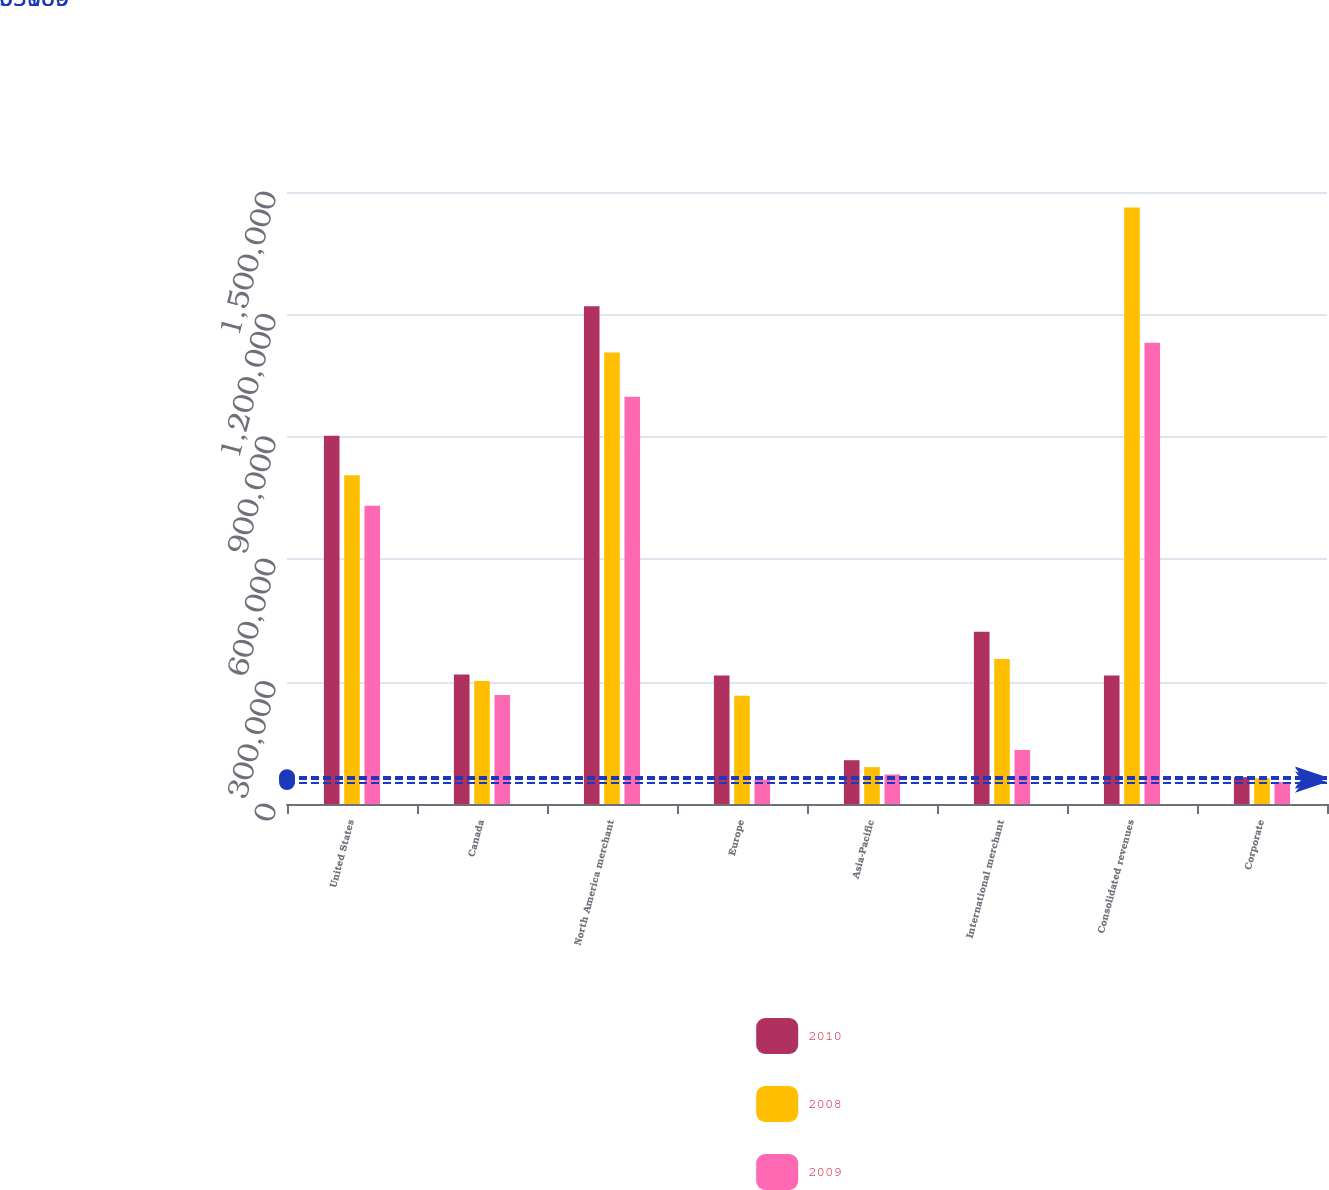Convert chart. <chart><loc_0><loc_0><loc_500><loc_500><stacked_bar_chart><ecel><fcel>United States<fcel>Canada<fcel>North America merchant<fcel>Europe<fcel>Asia-Pacific<fcel>International merchant<fcel>Consolidated revenues<fcel>Corporate<nl><fcel>2010<fcel>902844<fcel>317272<fcel>1.22012e+06<fcel>315023<fcel>107329<fcel>422352<fcel>315023<fcel>65806<nl><fcel>2008<fcel>805557<fcel>301294<fcel>1.10685e+06<fcel>265121<fcel>90334<fcel>355455<fcel>1.46231e+06<fcel>63189<nl><fcel>2009<fcel>731214<fcel>267249<fcel>998463<fcel>59778<fcel>72367<fcel>132145<fcel>1.13061e+06<fcel>53989<nl></chart> 